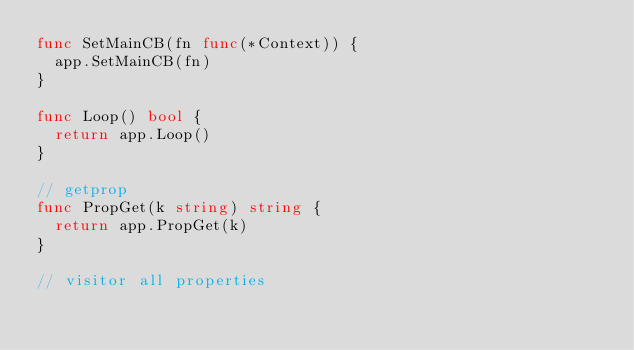<code> <loc_0><loc_0><loc_500><loc_500><_Go_>func SetMainCB(fn func(*Context)) {
	app.SetMainCB(fn)
}

func Loop() bool {
	return app.Loop()
}

// getprop
func PropGet(k string) string {
	return app.PropGet(k)
}

// visitor all properties</code> 